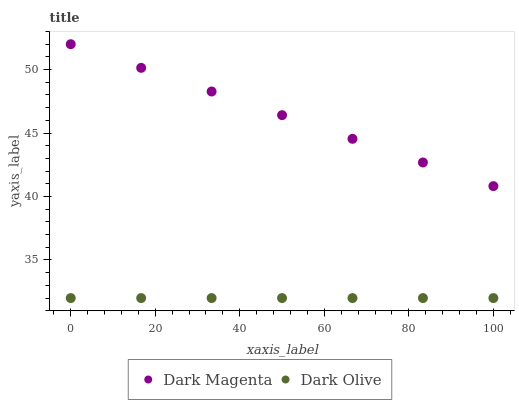Does Dark Olive have the minimum area under the curve?
Answer yes or no. Yes. Does Dark Magenta have the maximum area under the curve?
Answer yes or no. Yes. Does Dark Magenta have the minimum area under the curve?
Answer yes or no. No. Is Dark Olive the smoothest?
Answer yes or no. Yes. Is Dark Magenta the roughest?
Answer yes or no. Yes. Is Dark Magenta the smoothest?
Answer yes or no. No. Does Dark Olive have the lowest value?
Answer yes or no. Yes. Does Dark Magenta have the lowest value?
Answer yes or no. No. Does Dark Magenta have the highest value?
Answer yes or no. Yes. Is Dark Olive less than Dark Magenta?
Answer yes or no. Yes. Is Dark Magenta greater than Dark Olive?
Answer yes or no. Yes. Does Dark Olive intersect Dark Magenta?
Answer yes or no. No. 